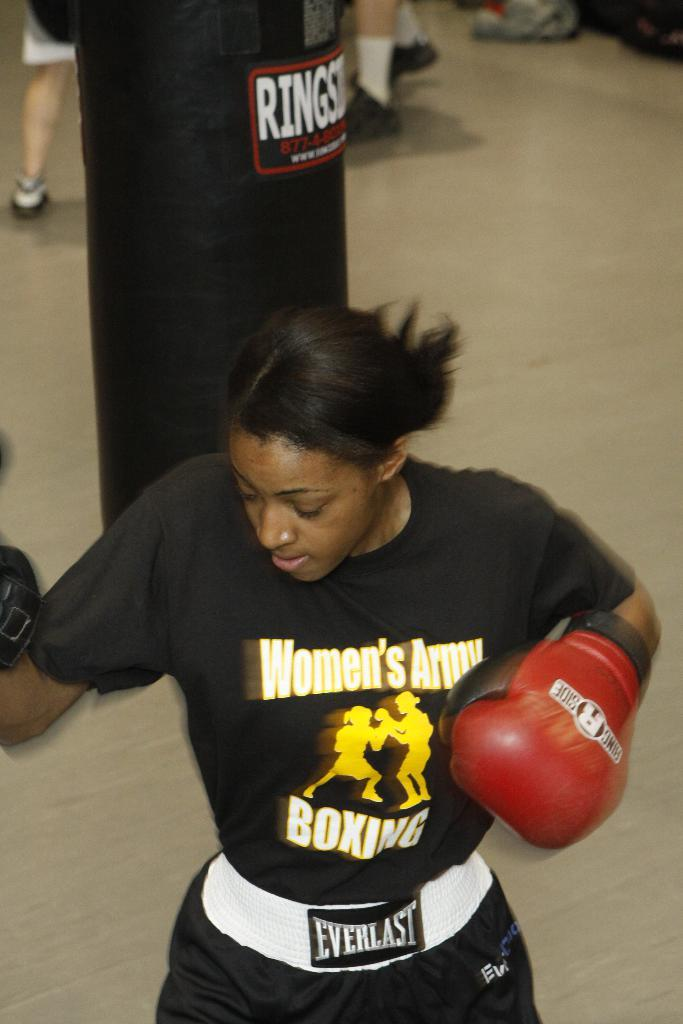<image>
Create a compact narrative representing the image presented. Woman from the Women's Army Boxing practicing her hits. 